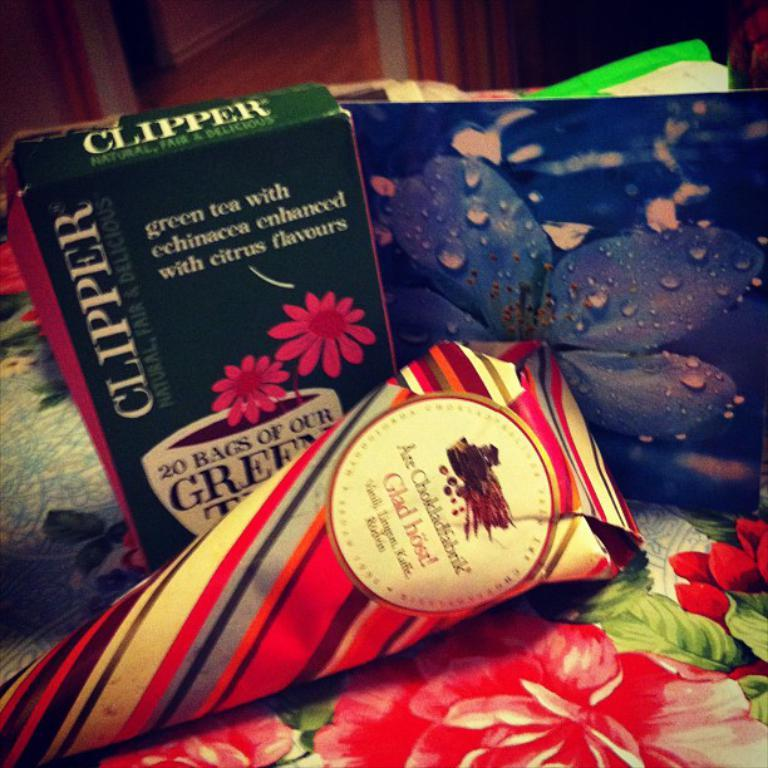<image>
Share a concise interpretation of the image provided. a box that says 'clipper' on the sides of it in white 